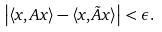<formula> <loc_0><loc_0><loc_500><loc_500>\left | \langle x , A x \rangle - \langle x , \tilde { A } x \rangle \right | < \epsilon .</formula> 